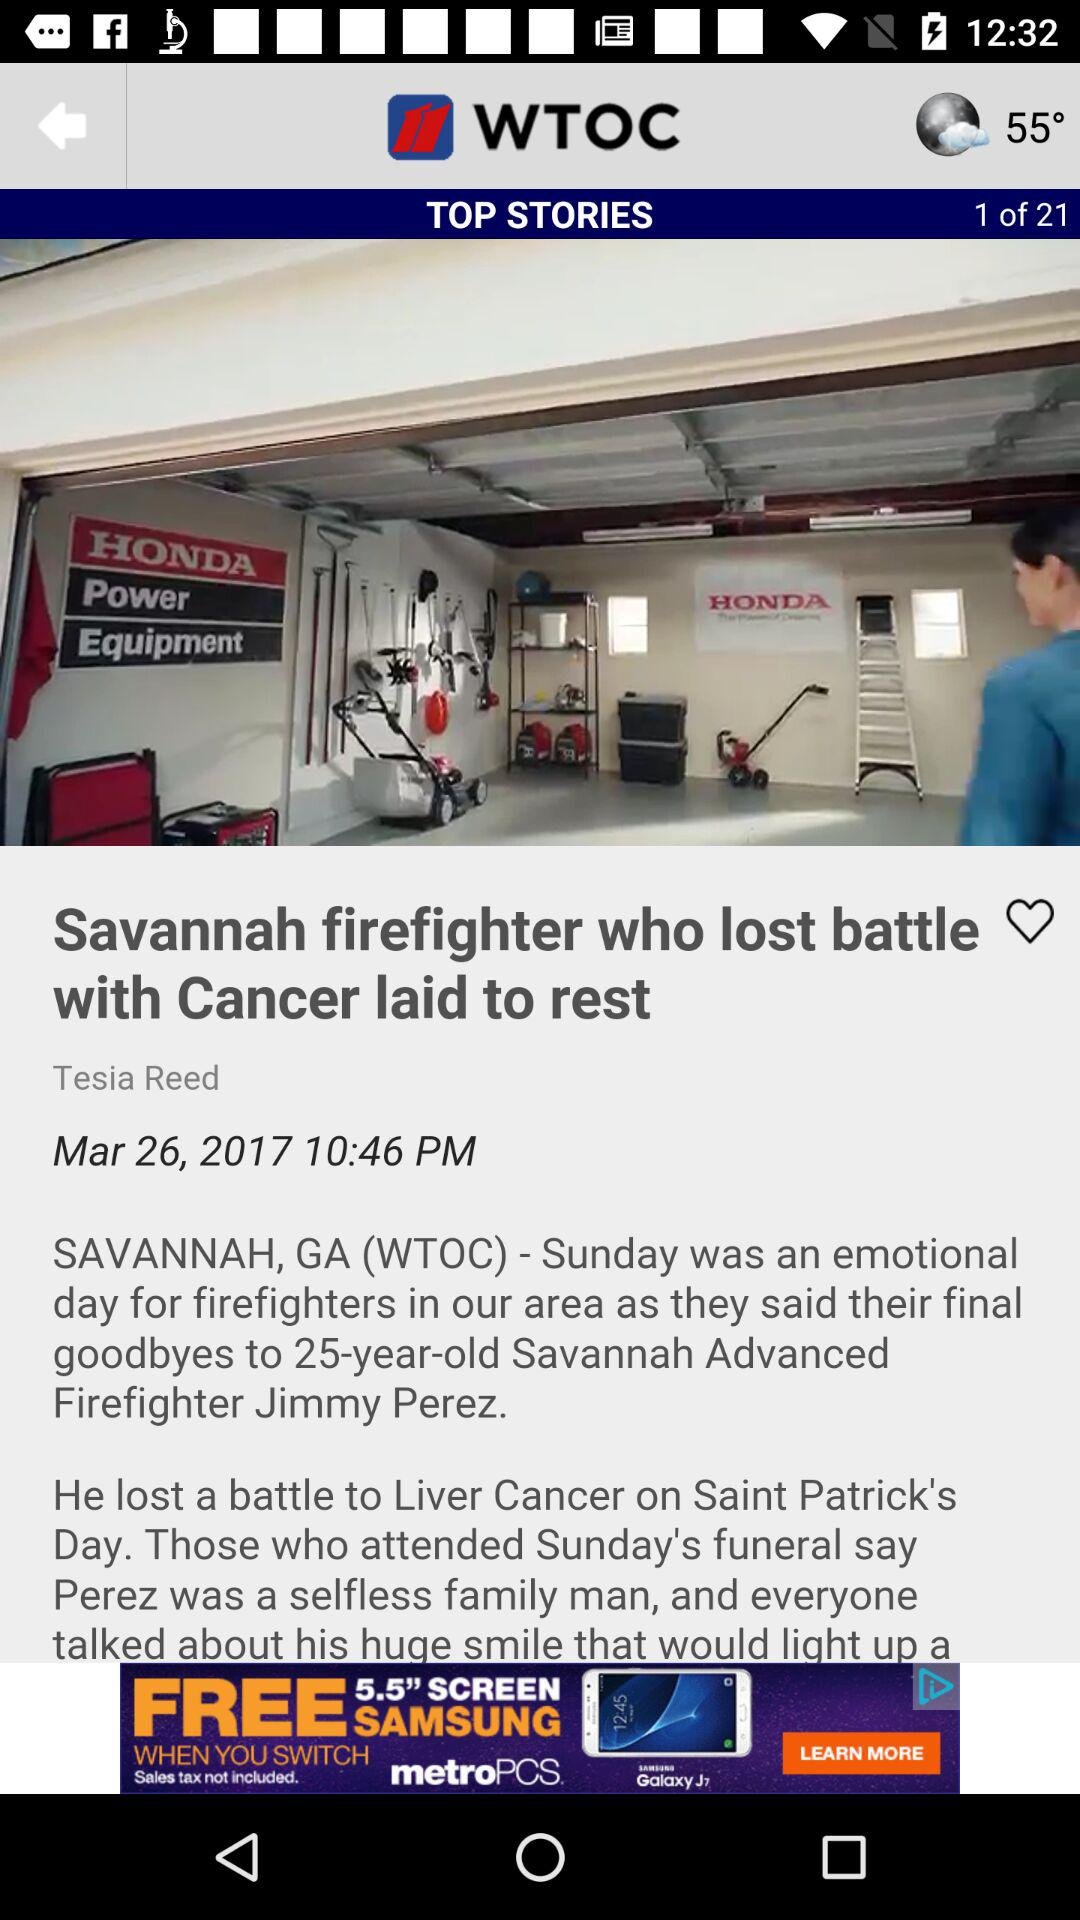What is the temperature showing on the screen? The temperature is 55°. 